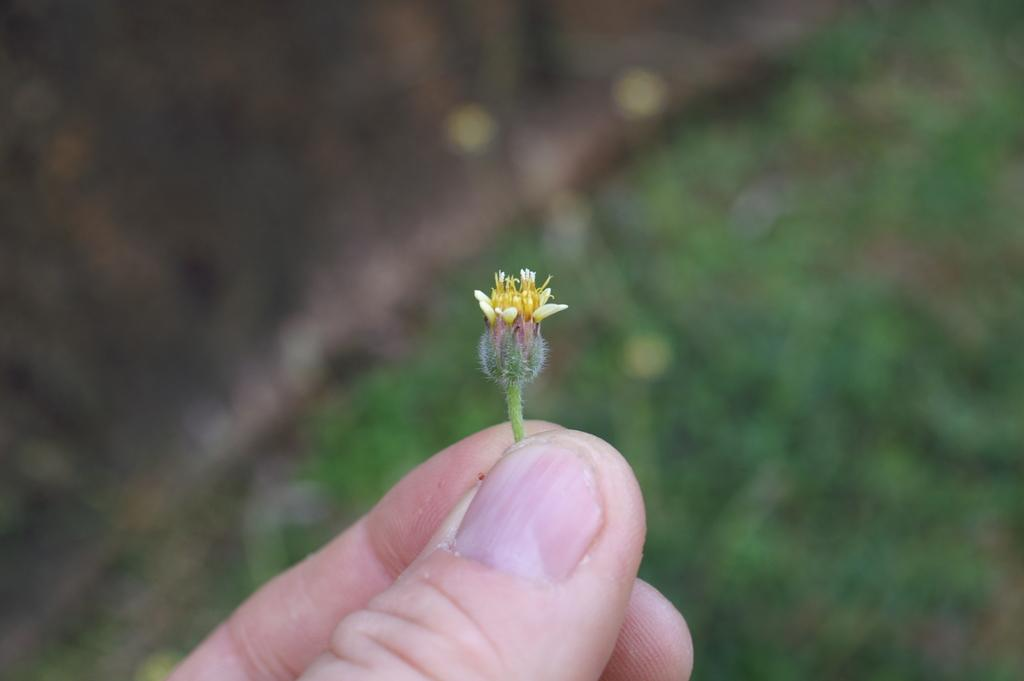What is the person holding in the image? There is a person's fingers holding a flower in the image. What color is the background of the image? The background of the image is green. How is the background of the image depicted? The background is blurred in the image. What type of army is visible in the image? There is no army present in the image. What does the flower taste like in the image? The image does not provide information about the taste of the flower. 